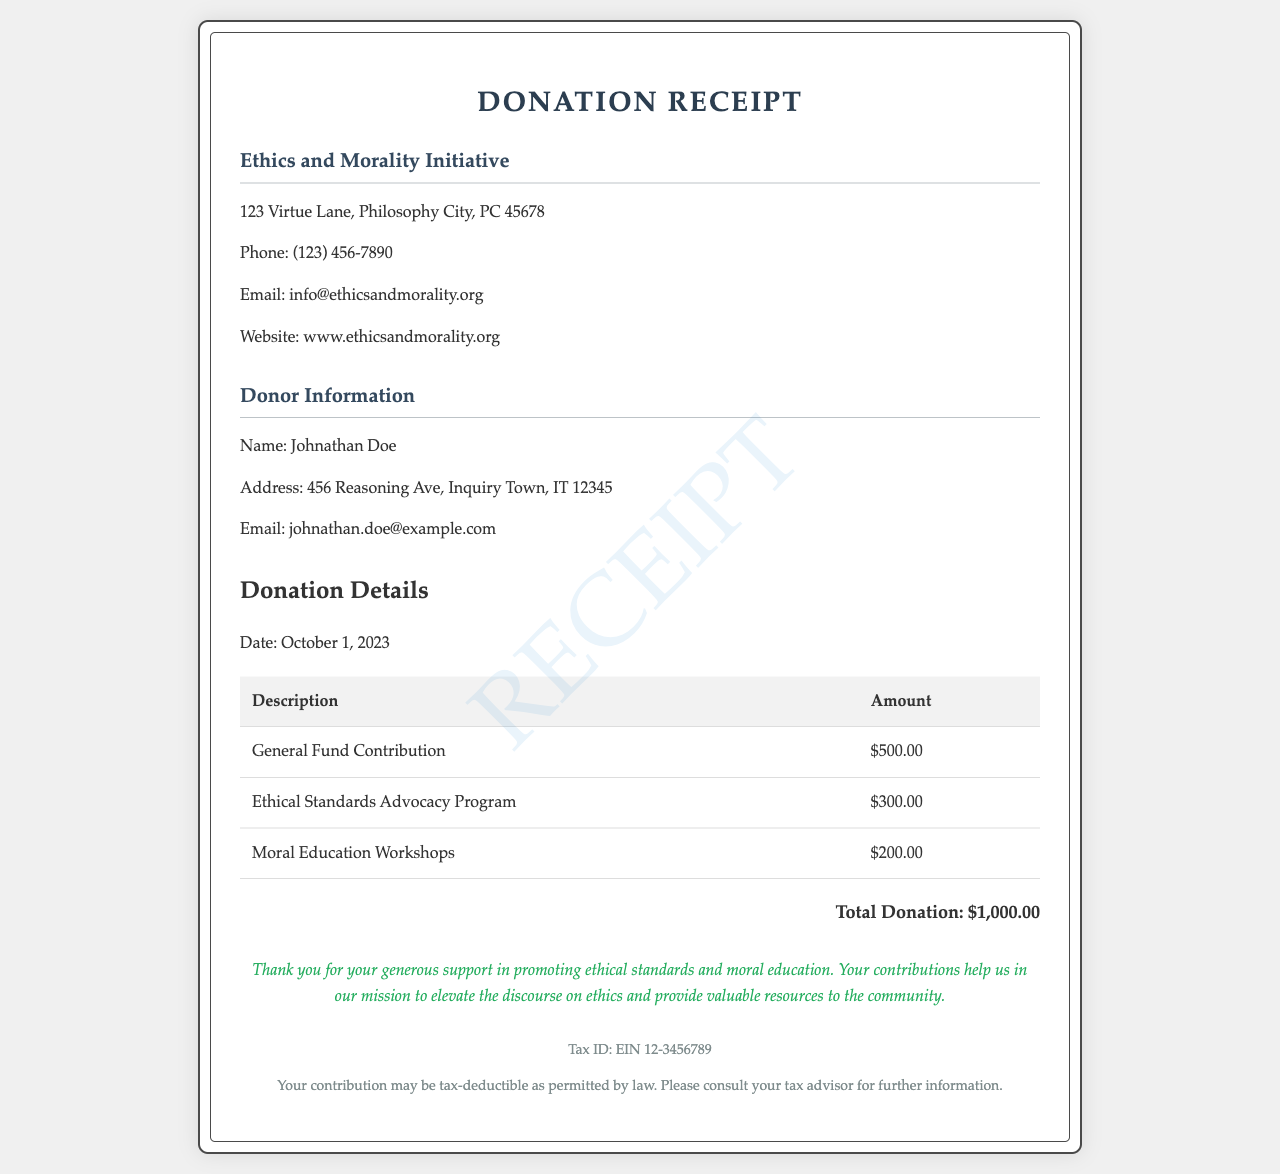What is the name of the nonprofit organization? The document specifies the name of the nonprofit organization, which is found in the header section.
Answer: Ethics and Morality Initiative What is the total donation amount? The total donation amount is clearly stated at the end of the donation details section of the document.
Answer: $1,000.00 Who is the donor? The document contains the donor's name in the donor information section.
Answer: Johnathan Doe What is the date of the donation? The date is provided in the donation details section, indicating when the contribution was made.
Answer: October 1, 2023 What are the amounts for the Ethical Standards Advocacy Program? The specific donation amount for this program can be found in the respective row of the donation table.
Answer: $300.00 Why is this donation significant for the organization? The thank you note explains the impact of the donations on the organization's mission.
Answer: It helps promote ethical standards and moral education What is the Tax ID number? The Tax ID number is mentioned in the tax information section of the document.
Answer: EIN 12-3456789 What is the donor's email address? The donor's email is provided in the donor information section for contact purposes.
Answer: johnathan.doe@example.com Which programs received donations? The programs are listed in the donation details table, specifying each contribution.
Answer: General Fund Contribution, Ethical Standards Advocacy Program, Moral Education Workshops 